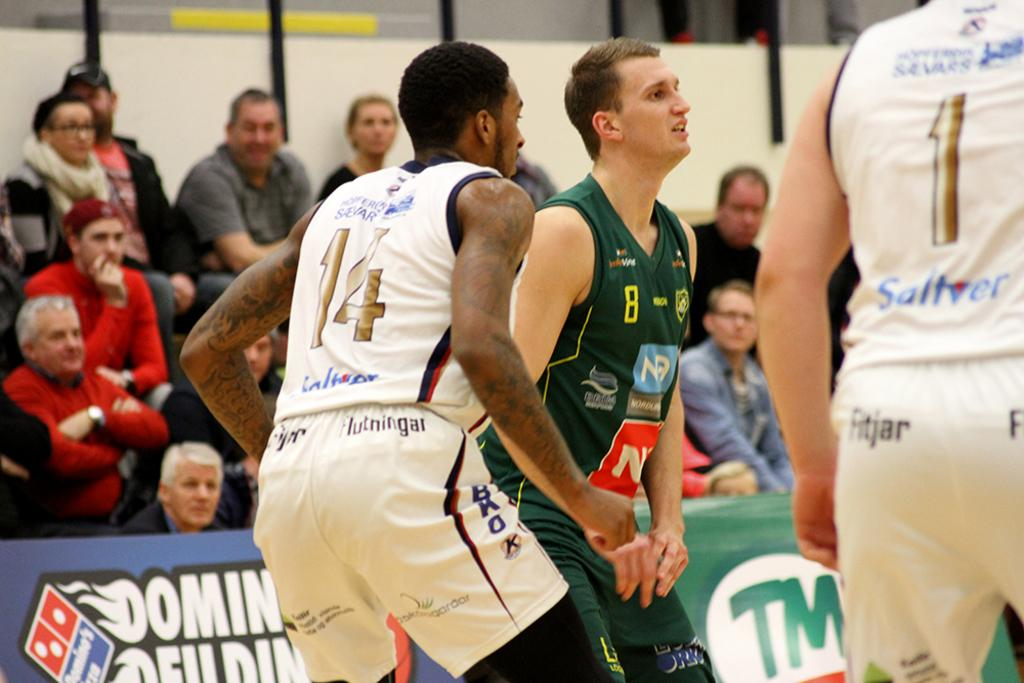<image>
Offer a succinct explanation of the picture presented. A basketball game with a Dominos ad in the background. 